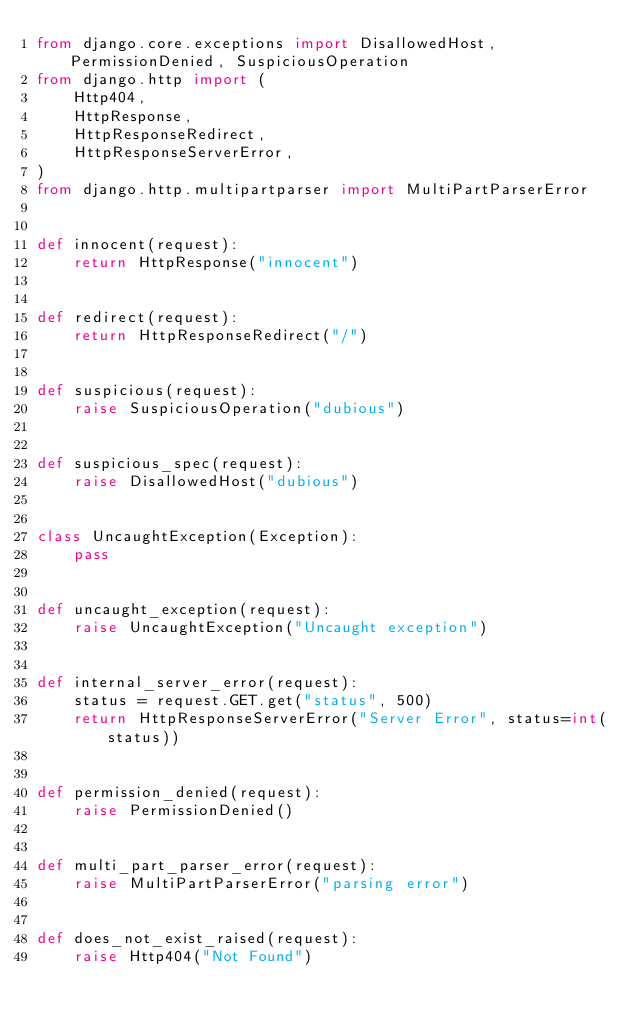<code> <loc_0><loc_0><loc_500><loc_500><_Python_>from django.core.exceptions import DisallowedHost, PermissionDenied, SuspiciousOperation
from django.http import (
    Http404,
    HttpResponse,
    HttpResponseRedirect,
    HttpResponseServerError,
)
from django.http.multipartparser import MultiPartParserError


def innocent(request):
    return HttpResponse("innocent")


def redirect(request):
    return HttpResponseRedirect("/")


def suspicious(request):
    raise SuspiciousOperation("dubious")


def suspicious_spec(request):
    raise DisallowedHost("dubious")


class UncaughtException(Exception):
    pass


def uncaught_exception(request):
    raise UncaughtException("Uncaught exception")


def internal_server_error(request):
    status = request.GET.get("status", 500)
    return HttpResponseServerError("Server Error", status=int(status))


def permission_denied(request):
    raise PermissionDenied()


def multi_part_parser_error(request):
    raise MultiPartParserError("parsing error")


def does_not_exist_raised(request):
    raise Http404("Not Found")
</code> 